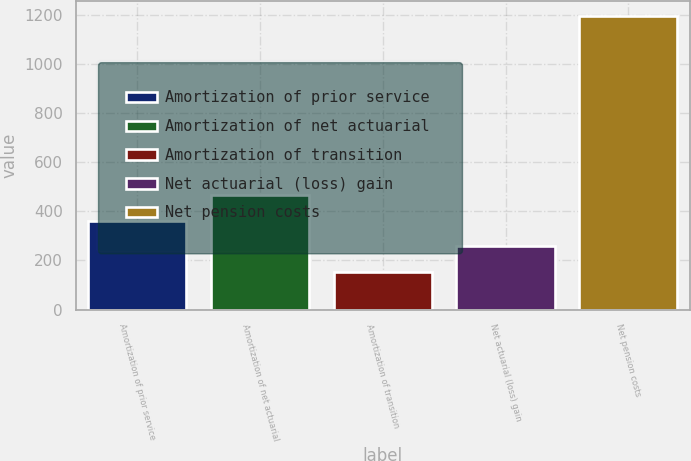Convert chart to OTSL. <chart><loc_0><loc_0><loc_500><loc_500><bar_chart><fcel>Amortization of prior service<fcel>Amortization of net actuarial<fcel>Amortization of transition<fcel>Net actuarial (loss) gain<fcel>Net pension costs<nl><fcel>361.2<fcel>465.3<fcel>153<fcel>257.1<fcel>1194<nl></chart> 